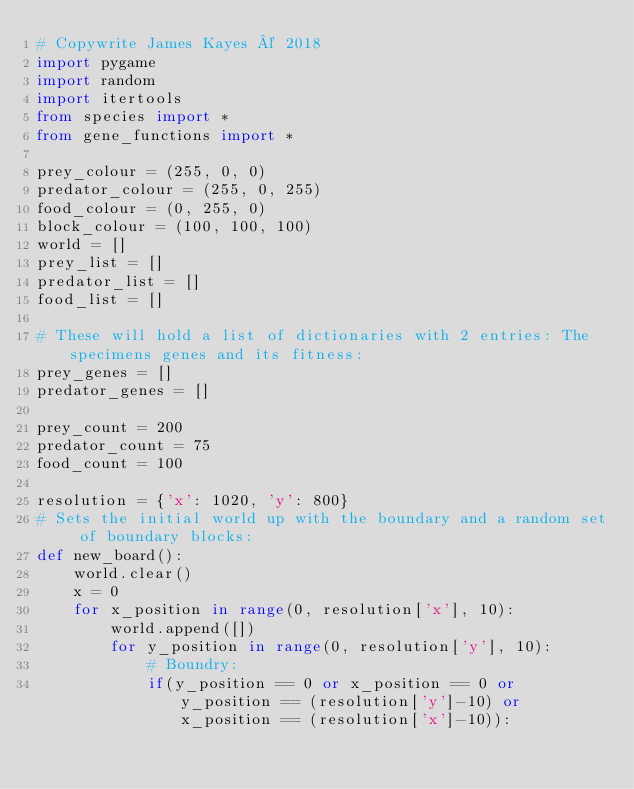Convert code to text. <code><loc_0><loc_0><loc_500><loc_500><_Python_># Copywrite James Kayes © 2018
import pygame
import random
import itertools
from species import *
from gene_functions import *

prey_colour = (255, 0, 0)
predator_colour = (255, 0, 255)
food_colour = (0, 255, 0)
block_colour = (100, 100, 100)
world = []
prey_list = []
predator_list = []
food_list = []

# These will hold a list of dictionaries with 2 entries: The specimens genes and its fitness:
prey_genes = []
predator_genes = [] 

prey_count = 200
predator_count = 75
food_count = 100

resolution = {'x': 1020, 'y': 800}
# Sets the initial world up with the boundary and a random set of boundary blocks:
def new_board():
    world.clear()
    x = 0
    for x_position in range(0, resolution['x'], 10):
        world.append([])
        for y_position in range(0, resolution['y'], 10):
            # Boundry:
            if(y_position == 0 or x_position == 0 or y_position == (resolution['y']-10) or x_position == (resolution['x']-10)):</code> 